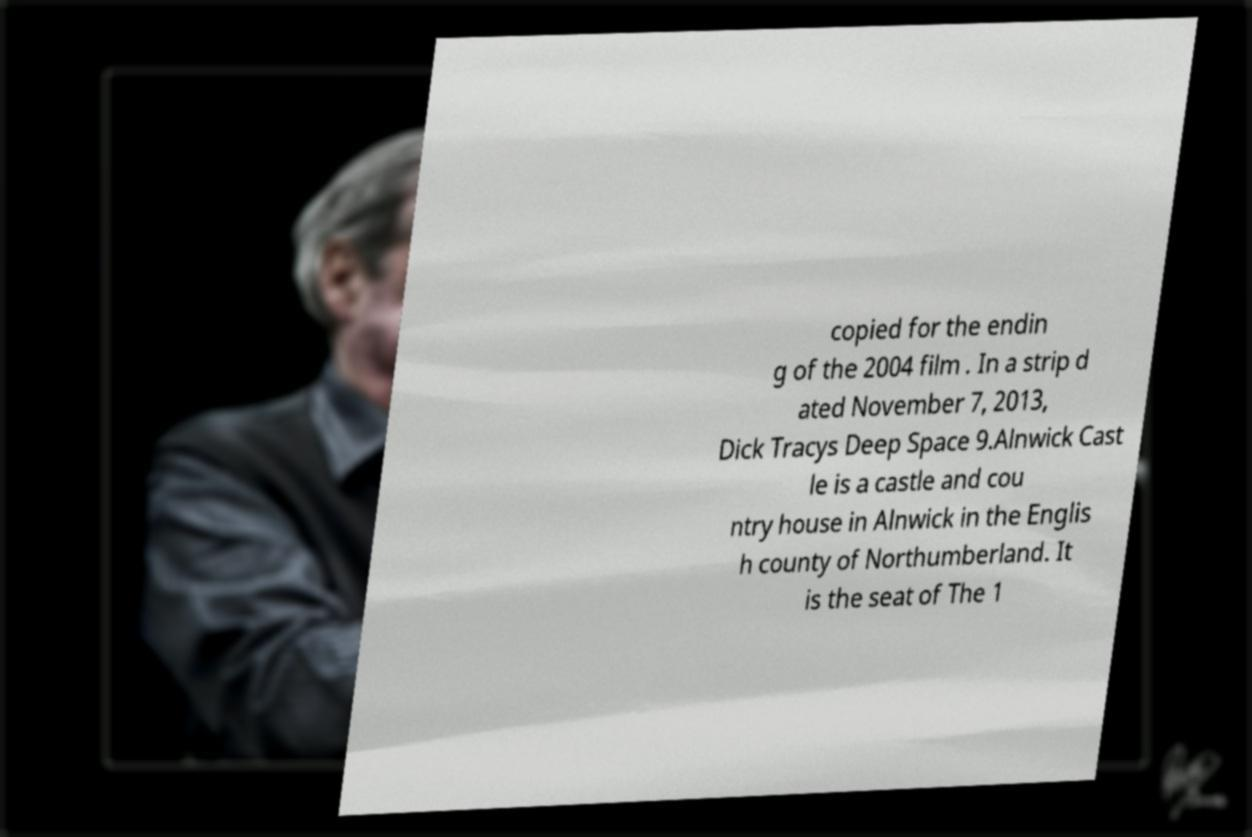What messages or text are displayed in this image? I need them in a readable, typed format. copied for the endin g of the 2004 film . In a strip d ated November 7, 2013, Dick Tracys Deep Space 9.Alnwick Cast le is a castle and cou ntry house in Alnwick in the Englis h county of Northumberland. It is the seat of The 1 